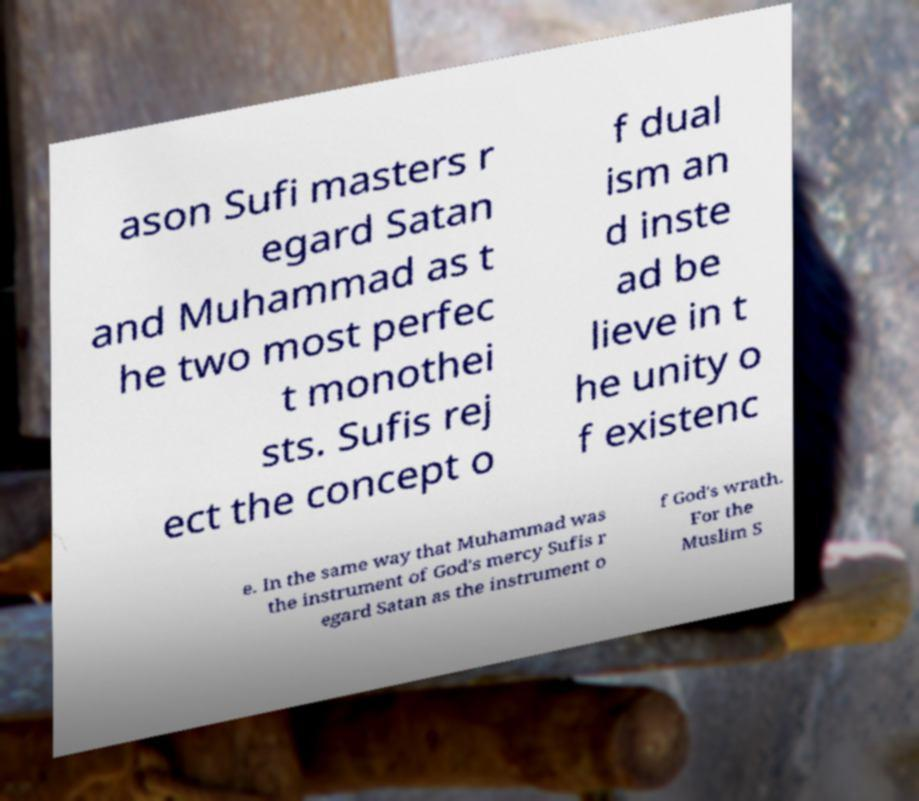What messages or text are displayed in this image? I need them in a readable, typed format. ason Sufi masters r egard Satan and Muhammad as t he two most perfec t monothei sts. Sufis rej ect the concept o f dual ism an d inste ad be lieve in t he unity o f existenc e. In the same way that Muhammad was the instrument of God's mercy Sufis r egard Satan as the instrument o f God's wrath. For the Muslim S 